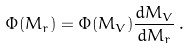Convert formula to latex. <formula><loc_0><loc_0><loc_500><loc_500>\Phi ( M _ { r } ) = \Phi ( M _ { V } ) \frac { d M _ { V } } { d M _ { r } } \, .</formula> 